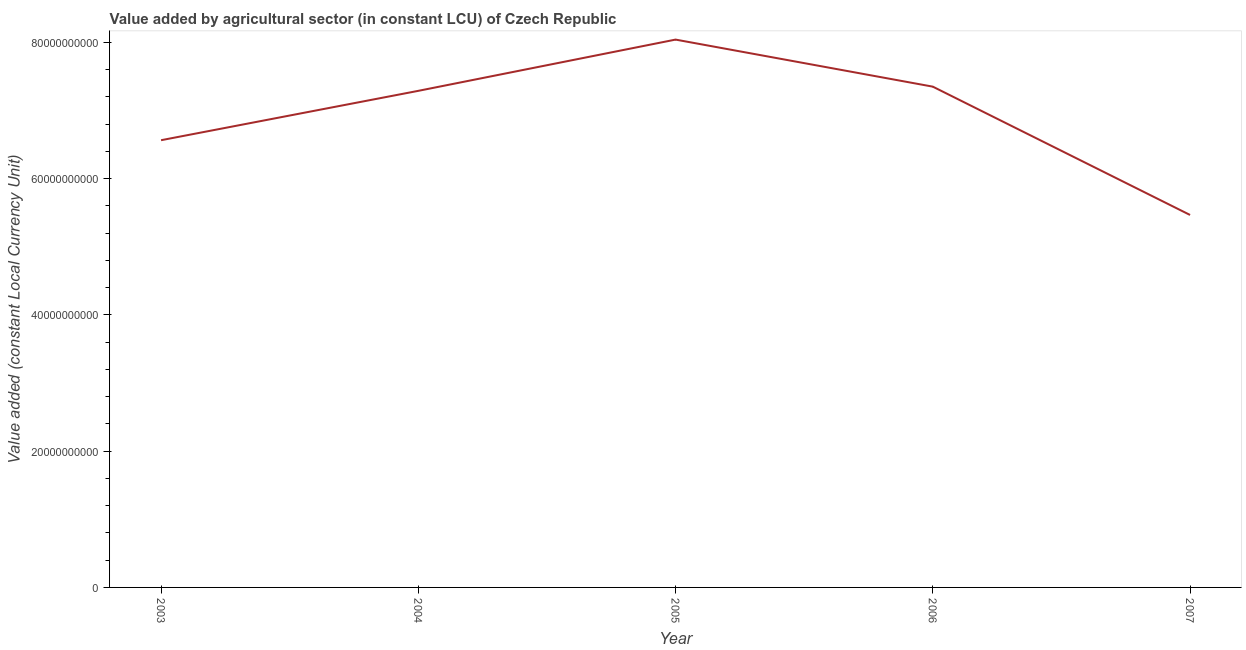What is the value added by agriculture sector in 2004?
Your answer should be very brief. 7.29e+1. Across all years, what is the maximum value added by agriculture sector?
Give a very brief answer. 8.04e+1. Across all years, what is the minimum value added by agriculture sector?
Give a very brief answer. 5.47e+1. In which year was the value added by agriculture sector maximum?
Provide a short and direct response. 2005. In which year was the value added by agriculture sector minimum?
Provide a succinct answer. 2007. What is the sum of the value added by agriculture sector?
Ensure brevity in your answer.  3.47e+11. What is the difference between the value added by agriculture sector in 2005 and 2007?
Ensure brevity in your answer.  2.57e+1. What is the average value added by agriculture sector per year?
Make the answer very short. 6.94e+1. What is the median value added by agriculture sector?
Offer a very short reply. 7.29e+1. In how many years, is the value added by agriculture sector greater than 48000000000 LCU?
Ensure brevity in your answer.  5. Do a majority of the years between 2004 and 2003 (inclusive) have value added by agriculture sector greater than 36000000000 LCU?
Keep it short and to the point. No. What is the ratio of the value added by agriculture sector in 2006 to that in 2007?
Give a very brief answer. 1.34. Is the value added by agriculture sector in 2005 less than that in 2006?
Your answer should be very brief. No. Is the difference between the value added by agriculture sector in 2005 and 2006 greater than the difference between any two years?
Ensure brevity in your answer.  No. What is the difference between the highest and the second highest value added by agriculture sector?
Offer a terse response. 6.90e+09. Is the sum of the value added by agriculture sector in 2005 and 2006 greater than the maximum value added by agriculture sector across all years?
Make the answer very short. Yes. What is the difference between the highest and the lowest value added by agriculture sector?
Your answer should be compact. 2.57e+1. In how many years, is the value added by agriculture sector greater than the average value added by agriculture sector taken over all years?
Provide a succinct answer. 3. Does the value added by agriculture sector monotonically increase over the years?
Make the answer very short. No. How many lines are there?
Offer a terse response. 1. What is the title of the graph?
Give a very brief answer. Value added by agricultural sector (in constant LCU) of Czech Republic. What is the label or title of the X-axis?
Offer a terse response. Year. What is the label or title of the Y-axis?
Offer a very short reply. Value added (constant Local Currency Unit). What is the Value added (constant Local Currency Unit) in 2003?
Your response must be concise. 6.56e+1. What is the Value added (constant Local Currency Unit) in 2004?
Keep it short and to the point. 7.29e+1. What is the Value added (constant Local Currency Unit) of 2005?
Your answer should be very brief. 8.04e+1. What is the Value added (constant Local Currency Unit) in 2006?
Keep it short and to the point. 7.35e+1. What is the Value added (constant Local Currency Unit) in 2007?
Provide a succinct answer. 5.47e+1. What is the difference between the Value added (constant Local Currency Unit) in 2003 and 2004?
Your answer should be very brief. -7.24e+09. What is the difference between the Value added (constant Local Currency Unit) in 2003 and 2005?
Provide a short and direct response. -1.48e+1. What is the difference between the Value added (constant Local Currency Unit) in 2003 and 2006?
Your answer should be very brief. -7.86e+09. What is the difference between the Value added (constant Local Currency Unit) in 2003 and 2007?
Your answer should be compact. 1.10e+1. What is the difference between the Value added (constant Local Currency Unit) in 2004 and 2005?
Offer a very short reply. -7.52e+09. What is the difference between the Value added (constant Local Currency Unit) in 2004 and 2006?
Your response must be concise. -6.16e+08. What is the difference between the Value added (constant Local Currency Unit) in 2004 and 2007?
Provide a short and direct response. 1.82e+1. What is the difference between the Value added (constant Local Currency Unit) in 2005 and 2006?
Provide a short and direct response. 6.90e+09. What is the difference between the Value added (constant Local Currency Unit) in 2005 and 2007?
Ensure brevity in your answer.  2.57e+1. What is the difference between the Value added (constant Local Currency Unit) in 2006 and 2007?
Provide a succinct answer. 1.88e+1. What is the ratio of the Value added (constant Local Currency Unit) in 2003 to that in 2004?
Provide a short and direct response. 0.9. What is the ratio of the Value added (constant Local Currency Unit) in 2003 to that in 2005?
Make the answer very short. 0.82. What is the ratio of the Value added (constant Local Currency Unit) in 2003 to that in 2006?
Ensure brevity in your answer.  0.89. What is the ratio of the Value added (constant Local Currency Unit) in 2003 to that in 2007?
Make the answer very short. 1.2. What is the ratio of the Value added (constant Local Currency Unit) in 2004 to that in 2005?
Offer a very short reply. 0.91. What is the ratio of the Value added (constant Local Currency Unit) in 2004 to that in 2006?
Provide a succinct answer. 0.99. What is the ratio of the Value added (constant Local Currency Unit) in 2004 to that in 2007?
Your response must be concise. 1.33. What is the ratio of the Value added (constant Local Currency Unit) in 2005 to that in 2006?
Offer a very short reply. 1.09. What is the ratio of the Value added (constant Local Currency Unit) in 2005 to that in 2007?
Your answer should be very brief. 1.47. What is the ratio of the Value added (constant Local Currency Unit) in 2006 to that in 2007?
Give a very brief answer. 1.34. 